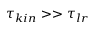Convert formula to latex. <formula><loc_0><loc_0><loc_500><loc_500>\tau _ { k i n } > > \tau _ { l r }</formula> 